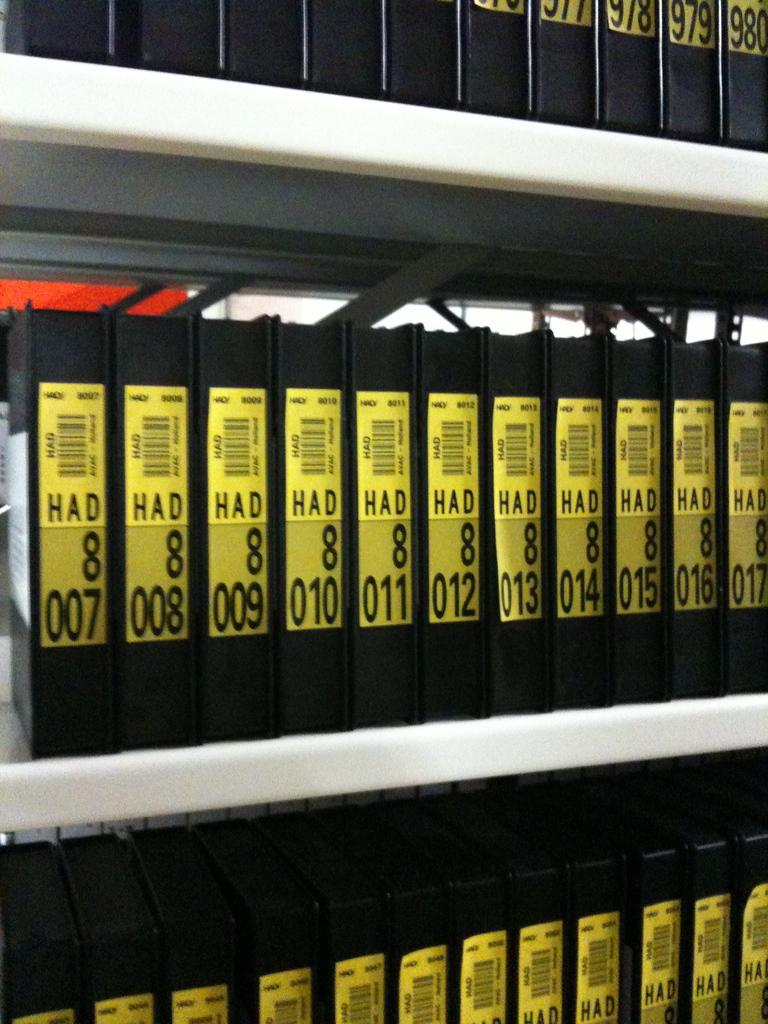<image>
Write a terse but informative summary of the picture. A large number of plastic cases that say HAD 8 on the sides are lined up on white shelves. 